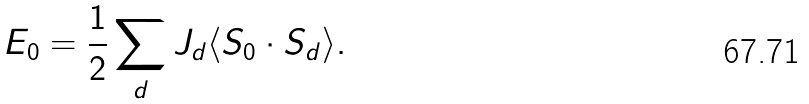<formula> <loc_0><loc_0><loc_500><loc_500>E _ { 0 } = \frac { 1 } { 2 } \sum _ { d } J _ { d } \langle { S } _ { 0 } \cdot { S } _ { d } \rangle .</formula> 